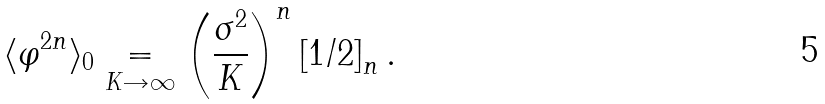<formula> <loc_0><loc_0><loc_500><loc_500>\langle \varphi ^ { 2 n } \rangle _ { 0 } \underset { K \rightarrow \infty } { = } \left ( \frac { \sigma ^ { 2 } } { K } \right ) ^ { n } \left [ 1 / 2 \right ] _ { n } .</formula> 